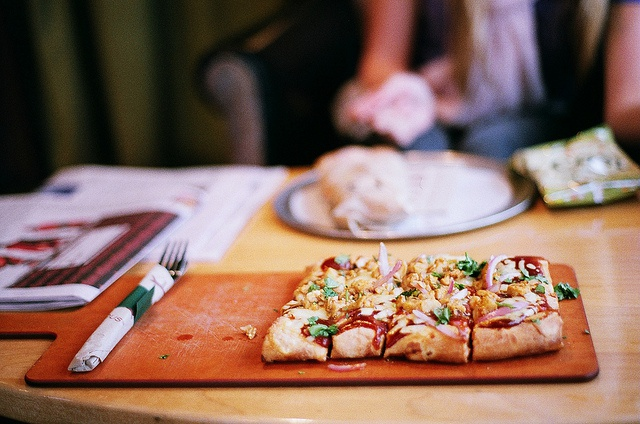Describe the objects in this image and their specific colors. I can see dining table in black, lavender, tan, and brown tones, pizza in black, lightgray, and tan tones, people in black, brown, darkgray, and gray tones, chair in black, brown, and maroon tones, and fork in black, lavender, darkgray, and teal tones in this image. 